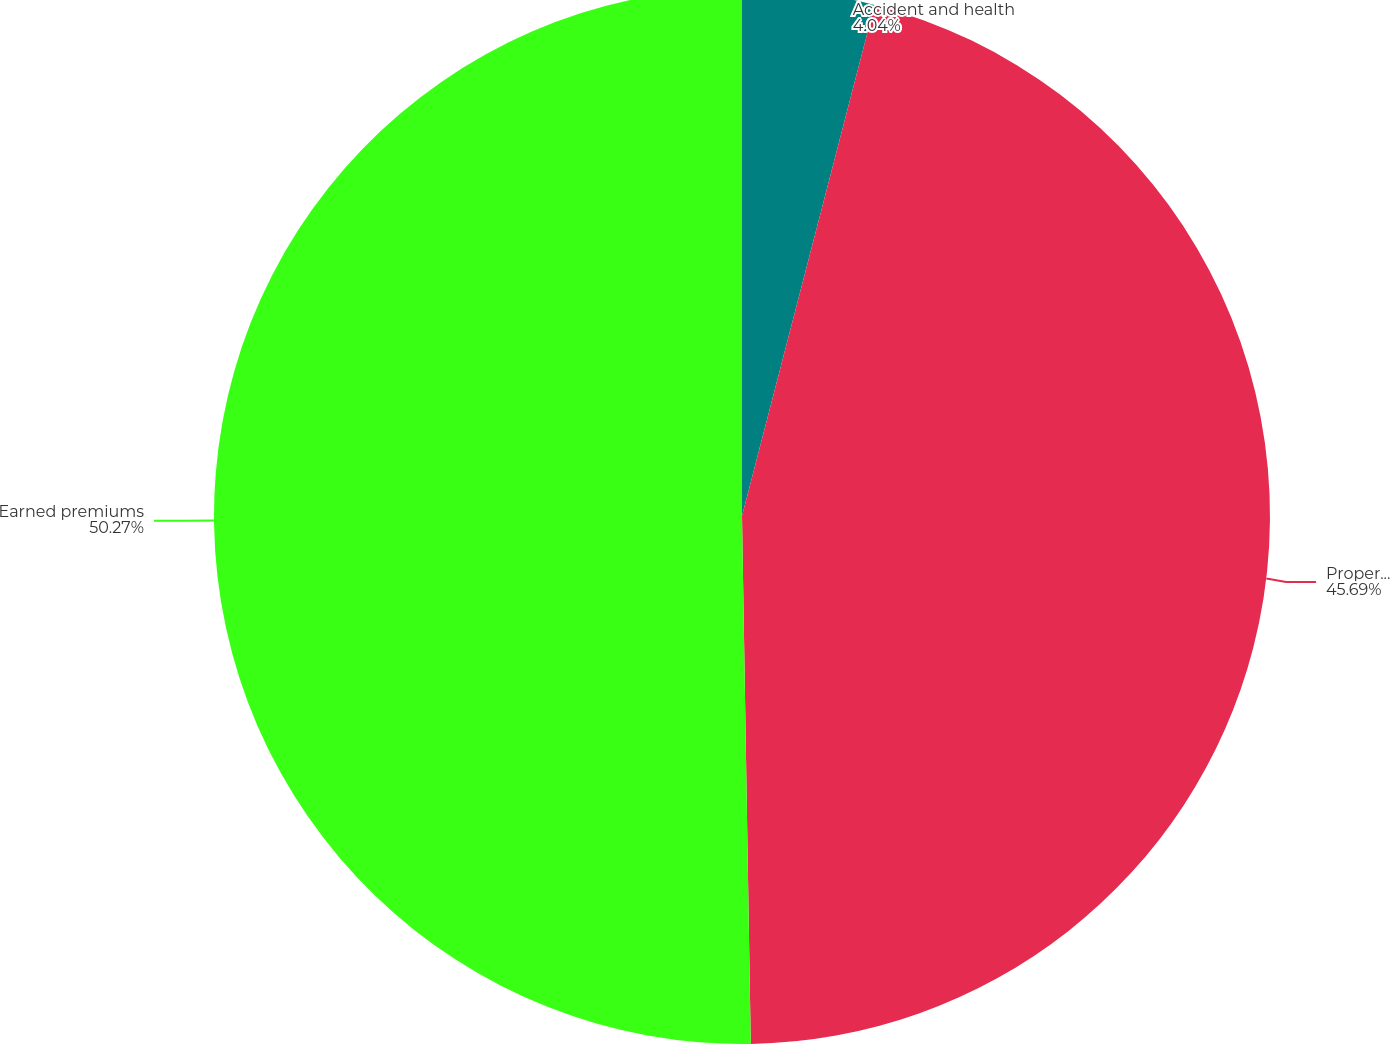Convert chart to OTSL. <chart><loc_0><loc_0><loc_500><loc_500><pie_chart><fcel>Accident and health<fcel>Property and casualty<fcel>Earned premiums<nl><fcel>4.04%<fcel>45.69%<fcel>50.26%<nl></chart> 